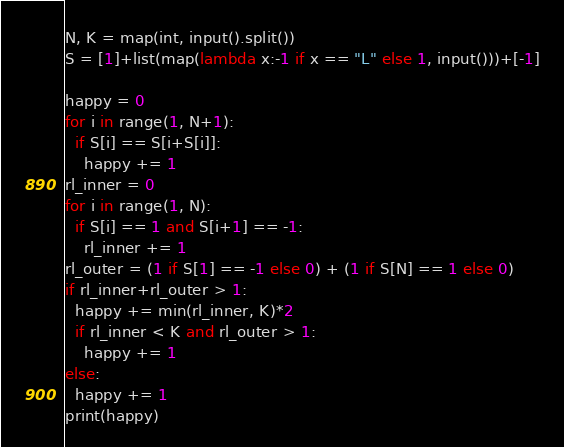<code> <loc_0><loc_0><loc_500><loc_500><_Python_>N, K = map(int, input().split())
S = [1]+list(map(lambda x:-1 if x == "L" else 1, input()))+[-1]

happy = 0
for i in range(1, N+1):
  if S[i] == S[i+S[i]]:
    happy += 1
rl_inner = 0
for i in range(1, N):
  if S[i] == 1 and S[i+1] == -1:
    rl_inner += 1
rl_outer = (1 if S[1] == -1 else 0) + (1 if S[N] == 1 else 0)
if rl_inner+rl_outer > 1:
  happy += min(rl_inner, K)*2
  if rl_inner < K and rl_outer > 1:
    happy += 1
else:
  happy += 1
print(happy)


</code> 